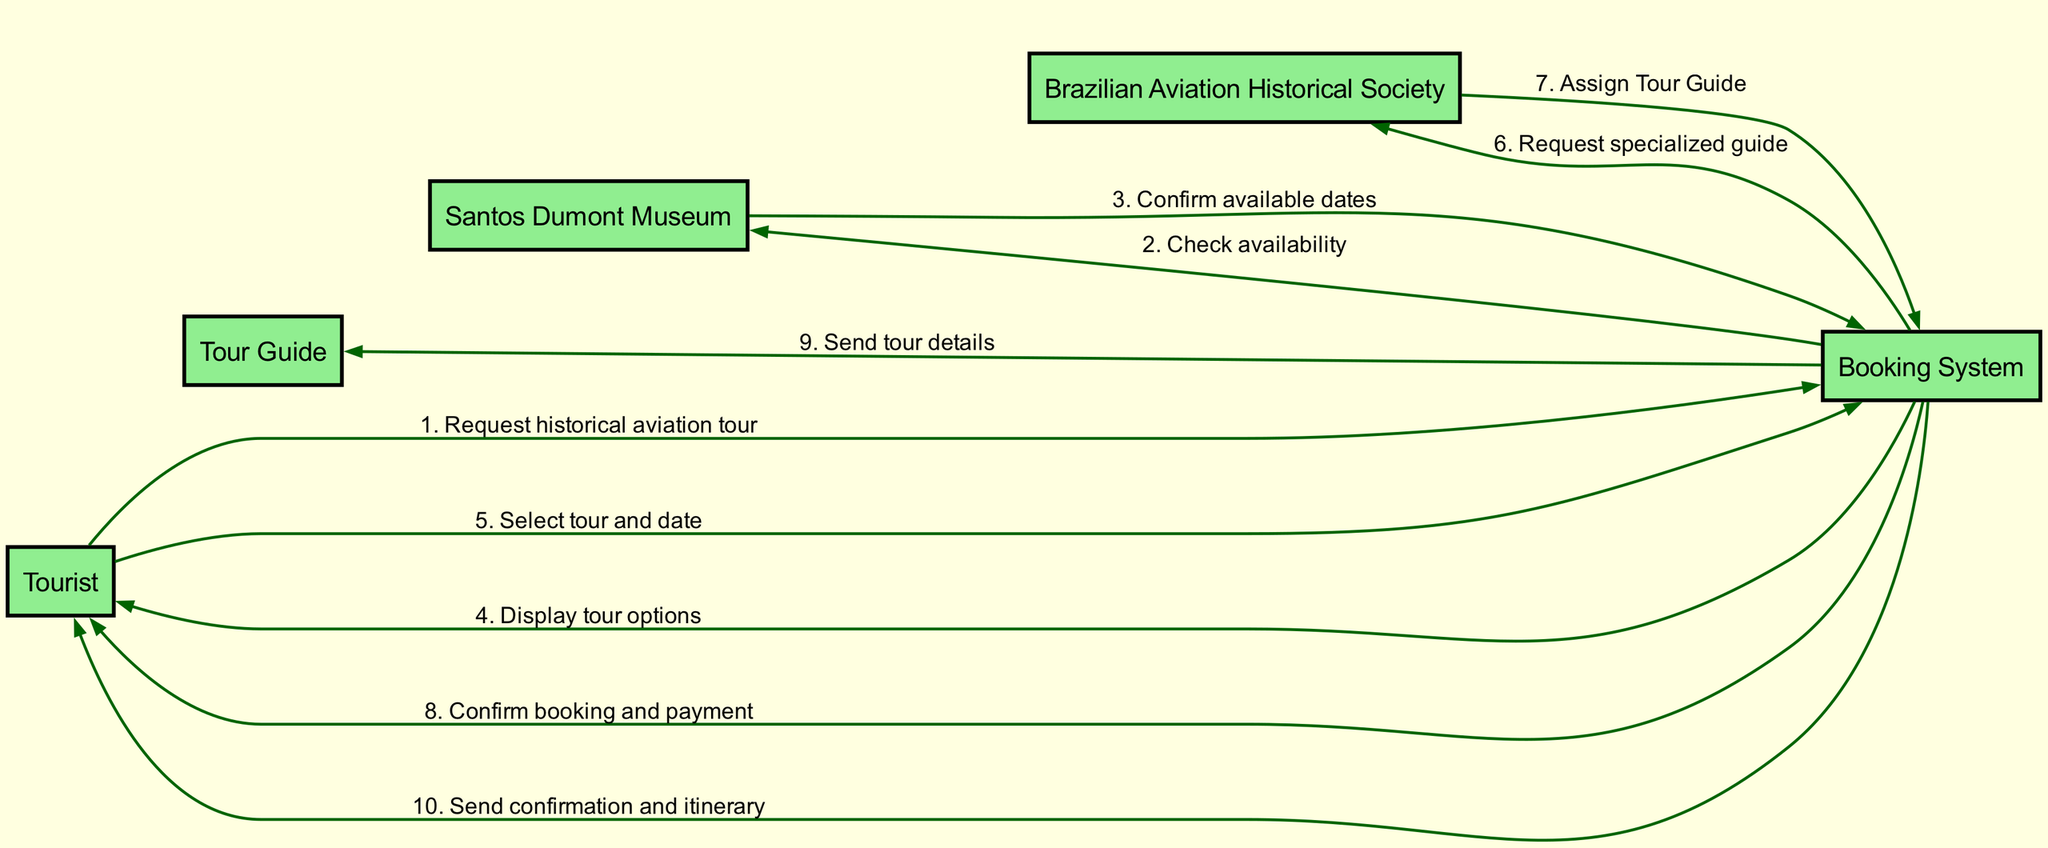What's the first action initiated by the Tourist? The first action initiated by the Tourist is to request a historical aviation tour, which is the initial message shown in the sequence diagram.
Answer: Request historical aviation tour Who confirms the available dates? The Santos Dumont Museum is responsible for confirming the available dates after the Booking System checks for availability. This is the response to the Booking System.
Answer: Santos Dumont Museum How many actors are involved in the booking process? The diagram shows a total of five distinct actors: Tourist, Tour Guide, Santos Dumont Museum, Brazilian Aviation Historical Society, and Booking System.
Answer: Five What is the last interaction that the Booking System has with the Tourist? The last interaction involves the Booking System sending confirmation and itinerary details back to the Tourist after booking and payment are confirmed. This concludes the sequence for the Tourist.
Answer: Send confirmation and itinerary Which actor is responsible for assigning the Tour Guide? The Brazilian Aviation Historical Society is the actor responsible for assigning the Tour Guide in response to the Booking System's request. This step is articulated in the sequence.
Answer: Brazilian Aviation Historical Society How many messages are exchanged between the Booking System and the Tourist? There are three messages exchanged between the Booking System and the Tourist: displaying tour options, confirming booking and payment, and sending confirmation and itinerary.
Answer: Three What is the action taken by the Booking System after the Tourist selects a tour and date? After the Tourist selects a tour and date, the Booking System requests a specialized guide from the Brazilian Aviation Historical Society. This is an essential part of the booking process indicated in the diagram.
Answer: Request specialized guide Which actor receives the tour details from the Booking System? The Tour Guide is the recipient of the tour details sent by the Booking System, which is part of preparing for the historical aviation tour.
Answer: Tour Guide What step follows the confirmation of available dates? The step that follows the confirmation of available dates is the Booking System displaying the available tour options to the Tourist. This is the next logical action in the sequence.
Answer: Display tour options 